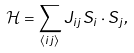<formula> <loc_0><loc_0><loc_500><loc_500>\mathcal { H } = \sum _ { \langle i j \rangle } J _ { i j } { S } _ { i } \cdot { S } _ { j } ,</formula> 